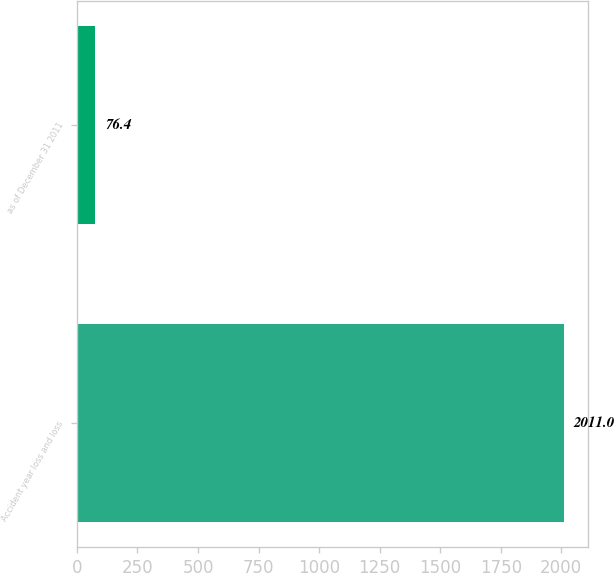Convert chart. <chart><loc_0><loc_0><loc_500><loc_500><bar_chart><fcel>Accident year loss and loss<fcel>as of December 31 2011<nl><fcel>2011<fcel>76.4<nl></chart> 